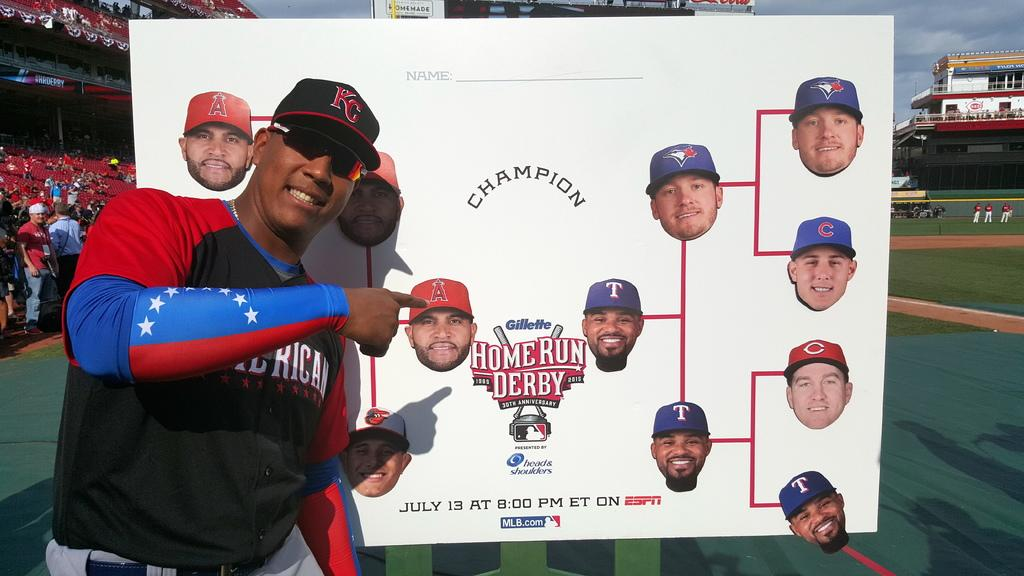<image>
Create a compact narrative representing the image presented. Someone points to the sign that says Home Run Derby. 